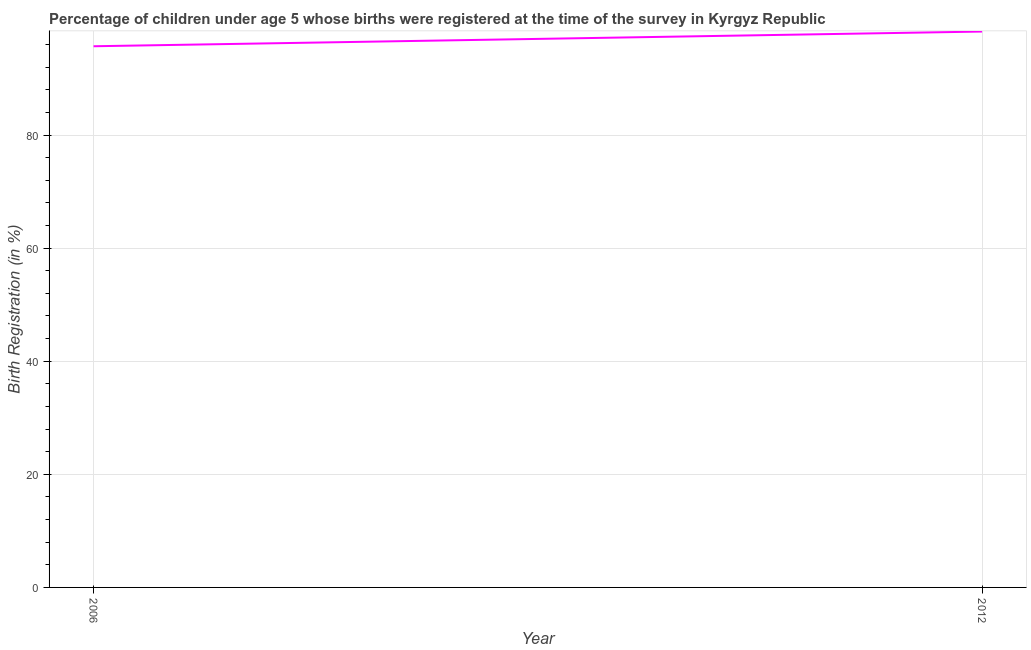What is the birth registration in 2012?
Offer a terse response. 98.3. Across all years, what is the maximum birth registration?
Keep it short and to the point. 98.3. Across all years, what is the minimum birth registration?
Offer a terse response. 95.7. In which year was the birth registration minimum?
Provide a short and direct response. 2006. What is the sum of the birth registration?
Provide a short and direct response. 194. What is the difference between the birth registration in 2006 and 2012?
Keep it short and to the point. -2.6. What is the average birth registration per year?
Keep it short and to the point. 97. What is the median birth registration?
Offer a very short reply. 97. What is the ratio of the birth registration in 2006 to that in 2012?
Offer a terse response. 0.97. Are the values on the major ticks of Y-axis written in scientific E-notation?
Make the answer very short. No. Does the graph contain any zero values?
Your answer should be very brief. No. Does the graph contain grids?
Keep it short and to the point. Yes. What is the title of the graph?
Ensure brevity in your answer.  Percentage of children under age 5 whose births were registered at the time of the survey in Kyrgyz Republic. What is the label or title of the X-axis?
Ensure brevity in your answer.  Year. What is the label or title of the Y-axis?
Keep it short and to the point. Birth Registration (in %). What is the Birth Registration (in %) in 2006?
Offer a terse response. 95.7. What is the Birth Registration (in %) in 2012?
Provide a succinct answer. 98.3. 